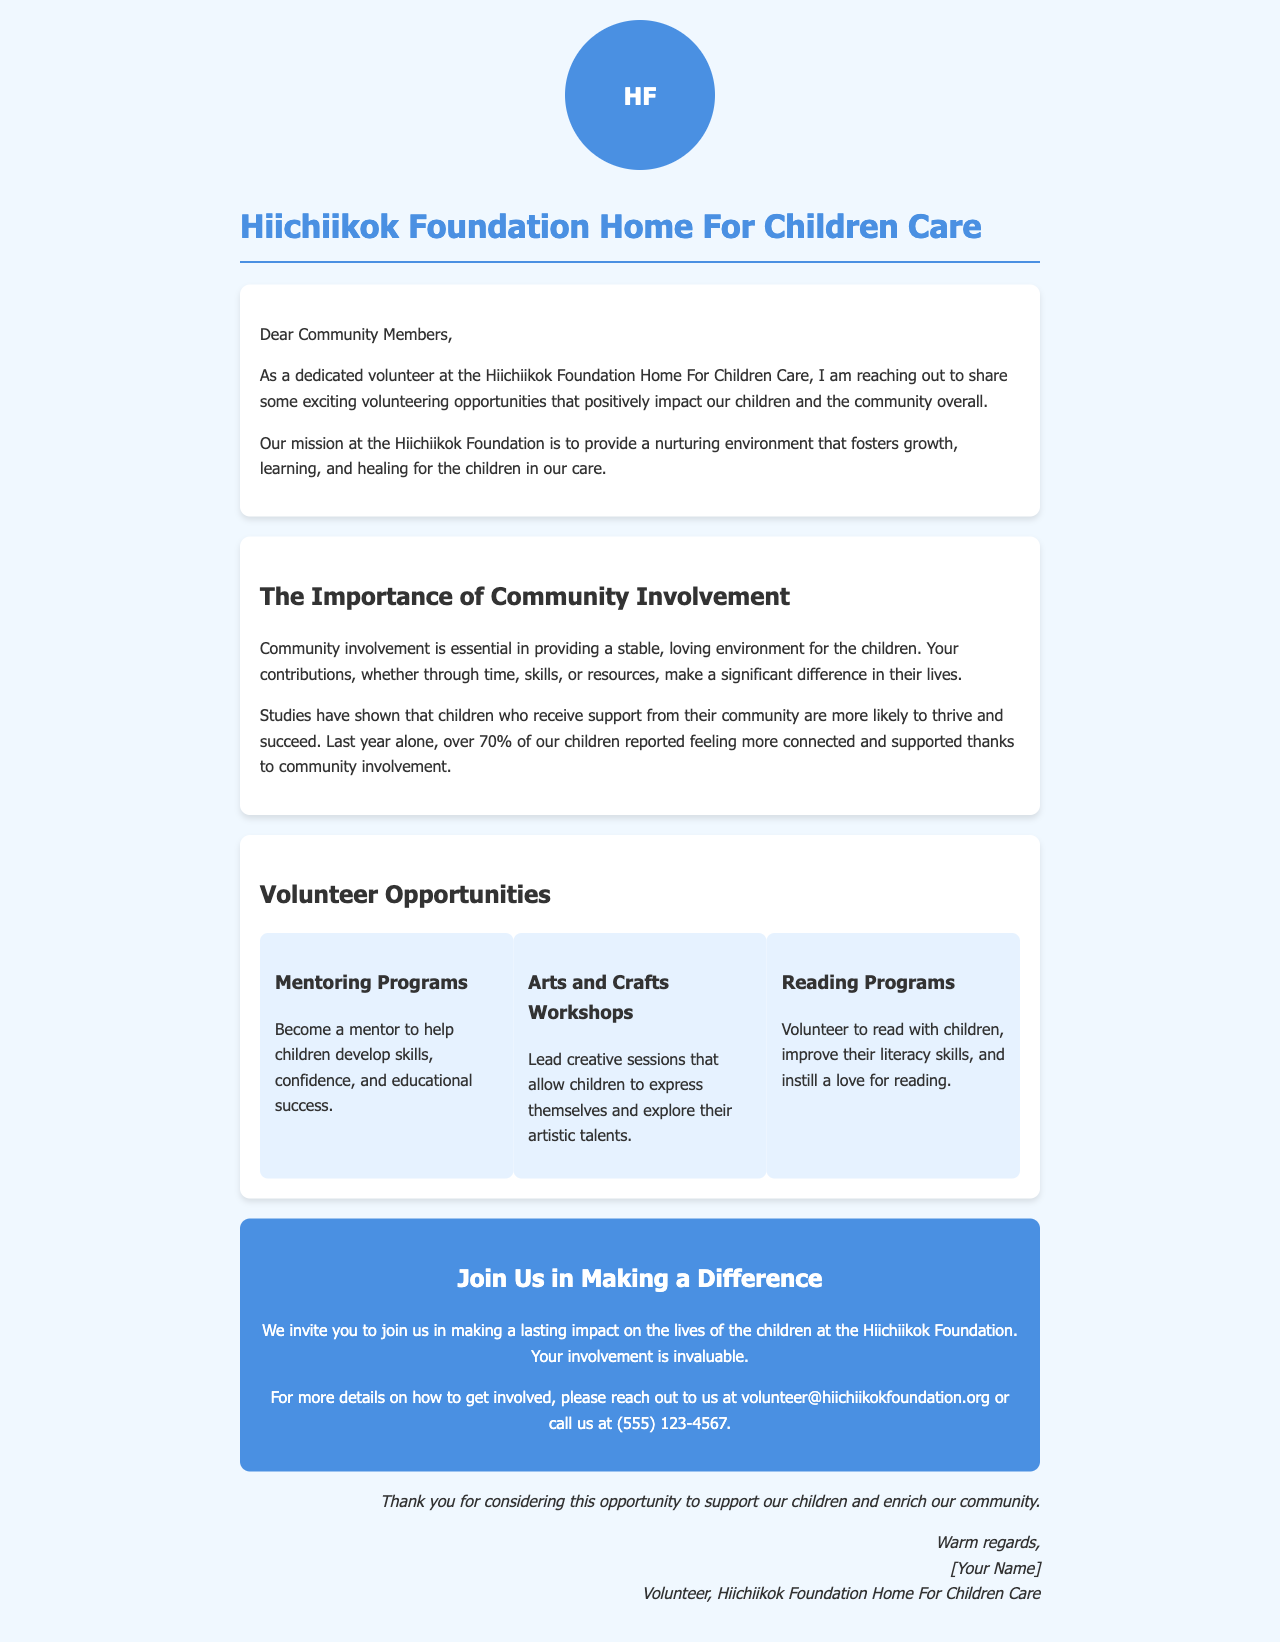what is the main purpose of the Hiichiikok Foundation? The document states that the mission is to provide a nurturing environment that fosters growth, learning, and healing for the children.
Answer: nurturing environment how many children reported feeling more connected last year? The document mentions that over 70% of the children felt more connected and supported due to community involvement.
Answer: 70% what type of program helps children develop skills and confidence? The document refers to "Mentoring Programs" as opportunities to help children develop skills, confidence, and educational success.
Answer: Mentoring Programs who can be contacted for more details on volunteer opportunities? The contact information provided is an email and phone number for reaching out about volunteer opportunities.
Answer: volunteer@hiichiikokfoundation.org what is one activity emphasized in the volunteer opportunities? One of the activities listed among the volunteer opportunities is leading "Arts and Crafts Workshops" for children.
Answer: Arts and Crafts Workshops why is community involvement important according to the document? The document highlights that community involvement is essential for providing a stable, loving environment for the children.
Answer: stable, loving environment how is the letter addressed to the recipients? The opening line of the document addresses the readers as “Dear Community Members.”
Answer: Dear Community Members what is the overall tone of the document? The document conveys a welcoming and informative tone to encourage community engagement and volunteering.
Answer: welcoming and informative 